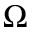Convert formula to latex. <formula><loc_0><loc_0><loc_500><loc_500>\Omega</formula> 